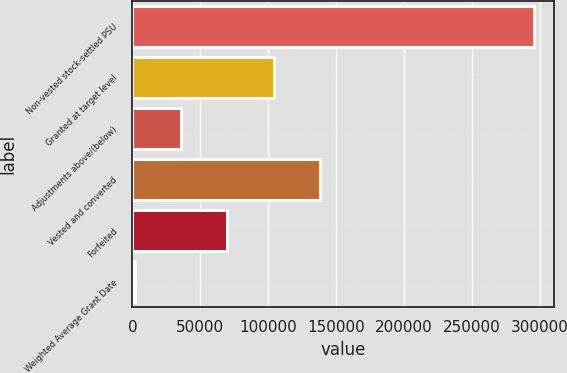Convert chart to OTSL. <chart><loc_0><loc_0><loc_500><loc_500><bar_chart><fcel>Non-vested stock-settled PSU<fcel>Granted at target level<fcel>Adjustments above/(below)<fcel>Vested and converted<fcel>Forfeited<fcel>Weighted Average Grant Date<nl><fcel>296037<fcel>103996<fcel>36010.6<fcel>137988<fcel>70003.2<fcel>2018<nl></chart> 